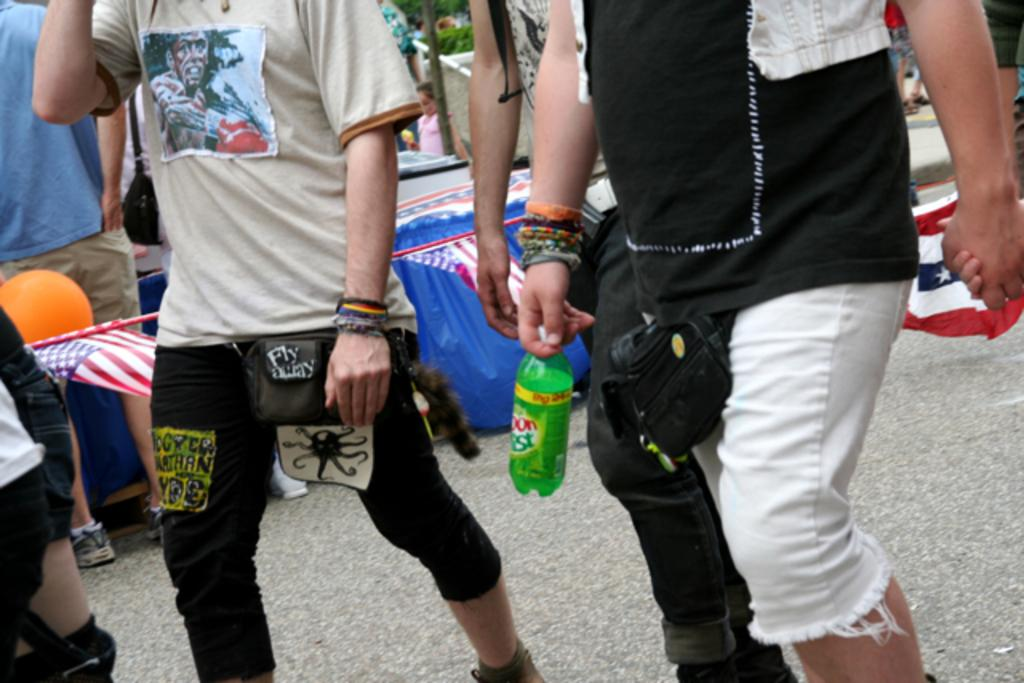What are the people in the image doing? The people in the image are walking on the road. Can you describe the position of one of the people in the image? One person is walking on the right side of the road. What is the person on the right side holding in his hand? The person on the right side is holding a bottle in his hand. What subject is the person on the right side teaching to the butter in the image? There is no butter present in the image, and the person on the right side is not teaching anything. 